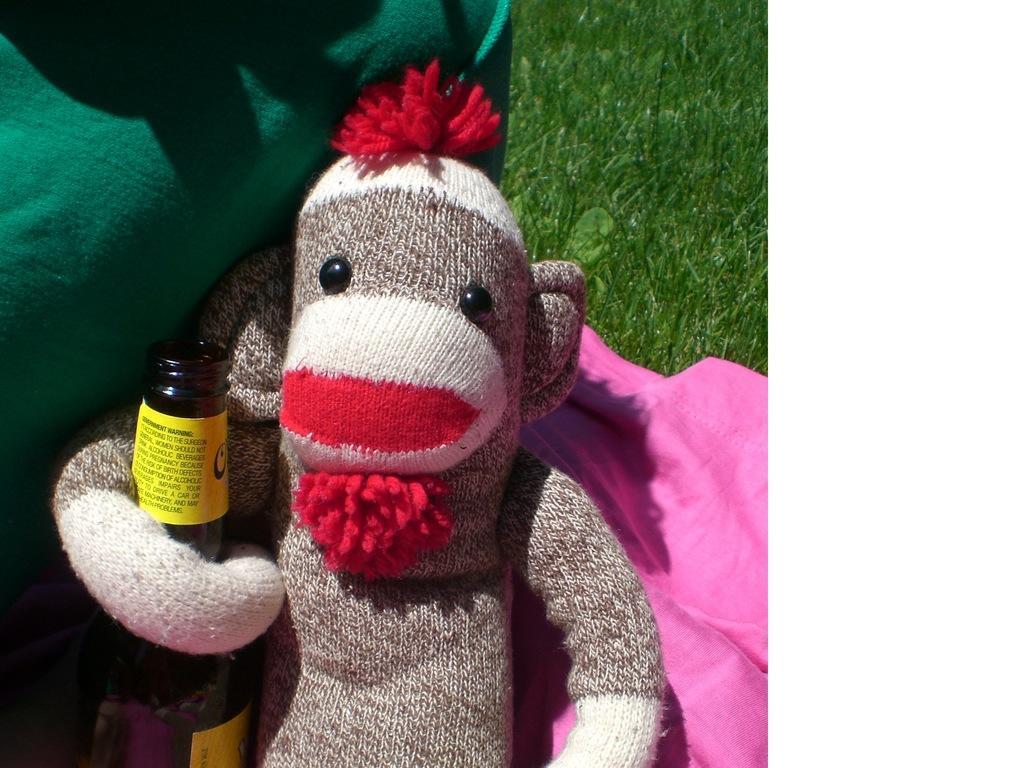Please provide a concise description of this image. In this image we can see a monkey toy made up of wool, beverage bottle and grass. 